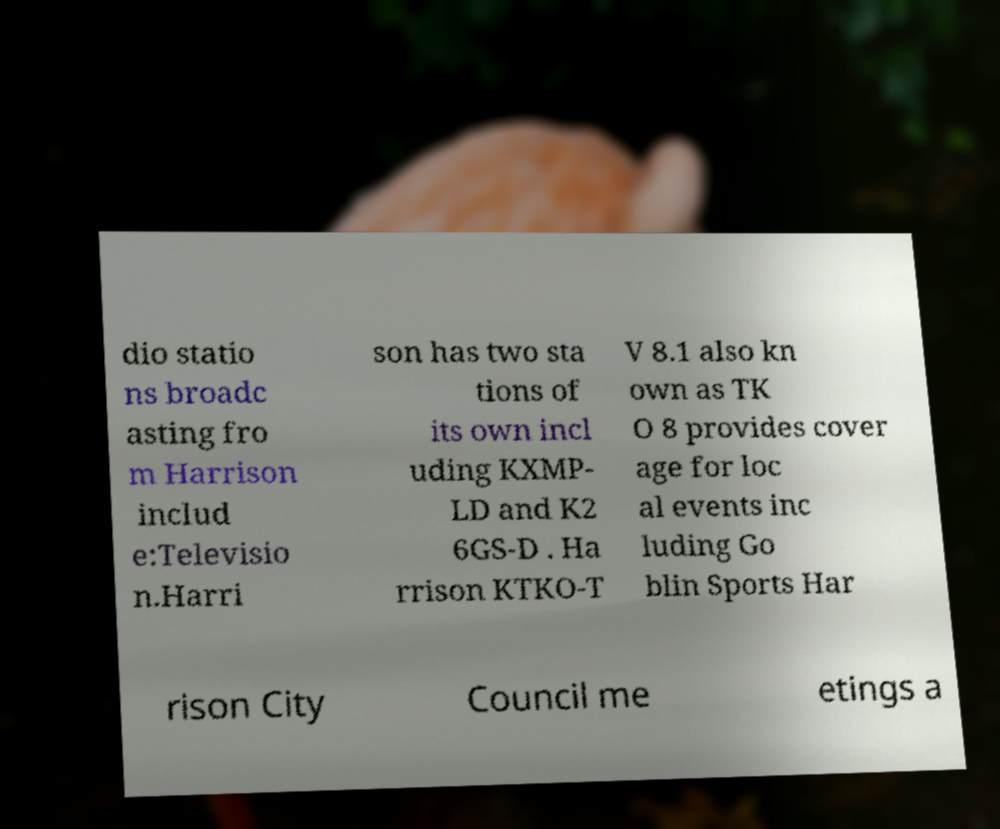Can you read and provide the text displayed in the image?This photo seems to have some interesting text. Can you extract and type it out for me? dio statio ns broadc asting fro m Harrison includ e:Televisio n.Harri son has two sta tions of its own incl uding KXMP- LD and K2 6GS-D . Ha rrison KTKO-T V 8.1 also kn own as TK O 8 provides cover age for loc al events inc luding Go blin Sports Har rison City Council me etings a 